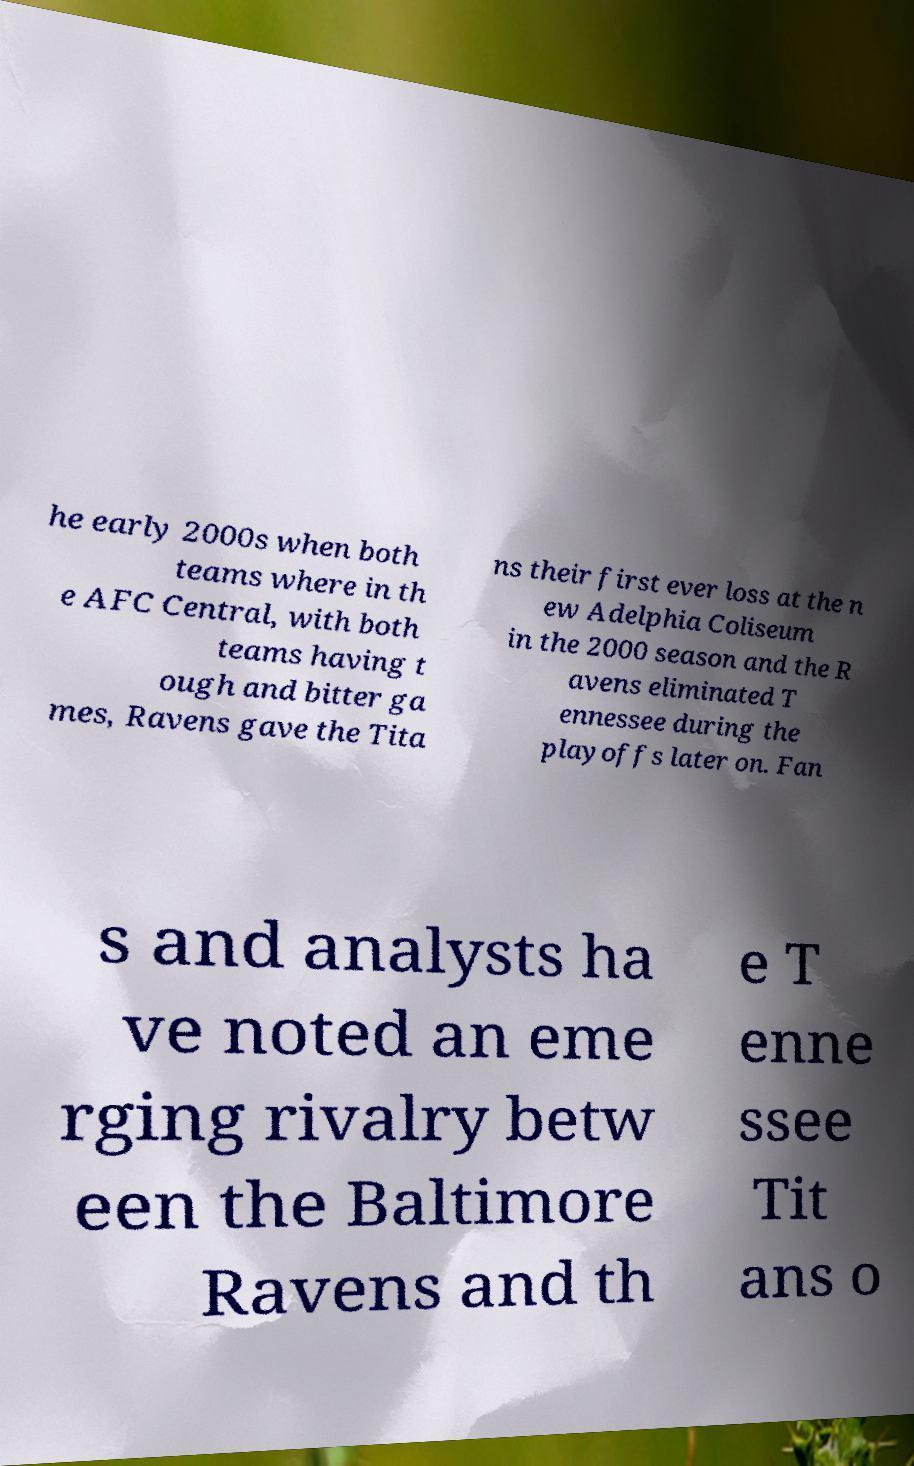I need the written content from this picture converted into text. Can you do that? he early 2000s when both teams where in th e AFC Central, with both teams having t ough and bitter ga mes, Ravens gave the Tita ns their first ever loss at the n ew Adelphia Coliseum in the 2000 season and the R avens eliminated T ennessee during the playoffs later on. Fan s and analysts ha ve noted an eme rging rivalry betw een the Baltimore Ravens and th e T enne ssee Tit ans o 